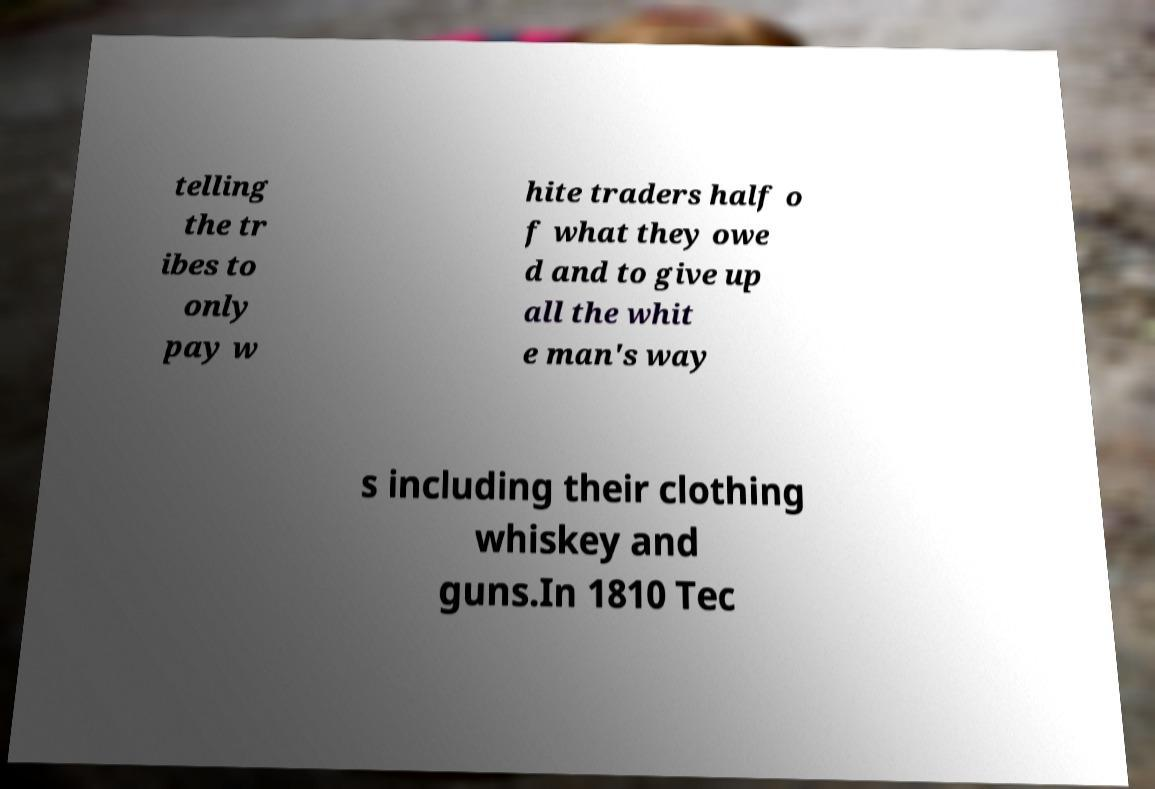I need the written content from this picture converted into text. Can you do that? telling the tr ibes to only pay w hite traders half o f what they owe d and to give up all the whit e man's way s including their clothing whiskey and guns.In 1810 Tec 